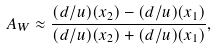Convert formula to latex. <formula><loc_0><loc_0><loc_500><loc_500>A _ { W } \approx \frac { ( d / u ) ( x _ { 2 } ) - ( d / u ) ( x _ { 1 } ) } { ( d / u ) ( x _ { 2 } ) + ( d / u ) ( x _ { 1 } ) } ,</formula> 